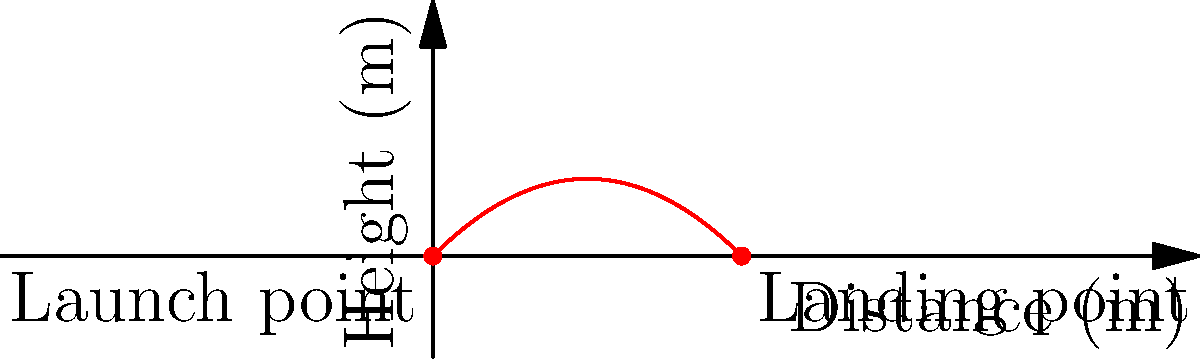As a method actor preparing for a role as a character with acrophobia (fear of heights), you need to understand the trajectory of a thrown object to realistically portray anxiety during a scene. A projectile is launched from ground level at an initial velocity of 20 m/s and an angle of 45° above the horizontal. Assuming no air resistance, what is the maximum height reached by the projectile? Express your answer in meters, rounded to one decimal place. To find the maximum height, we'll follow these steps:

1) The vertical component of the initial velocity is:
   $$v_{0y} = v_0 \sin(\theta) = 20 \sin(45°) = 20 \cdot \frac{\sqrt{2}}{2} \approx 14.14 \text{ m/s}$$

2) The time to reach maximum height is when the vertical velocity becomes zero:
   $$v_y = v_{0y} - gt = 0$$
   $$t = \frac{v_{0y}}{g} = \frac{14.14}{9.8} \approx 1.44 \text{ s}$$

3) The maximum height is found using the equation:
   $$y = v_{0y}t - \frac{1}{2}gt^2$$

4) Substituting the values:
   $$y_{\text{max}} = 14.14 \cdot 1.44 - \frac{1}{2} \cdot 9.8 \cdot 1.44^2$$
   $$y_{\text{max}} = 20.36 - 10.18 = 10.18 \text{ m}$$

5) Rounding to one decimal place:
   $$y_{\text{max}} \approx 10.2 \text{ m}$$

This result represents the peak of the parabolic trajectory, which would be the most anxiety-inducing point for a character with acrophobia.
Answer: 10.2 m 